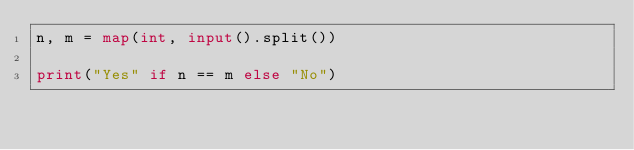Convert code to text. <code><loc_0><loc_0><loc_500><loc_500><_Python_>n, m = map(int, input().split())

print("Yes" if n == m else "No")</code> 